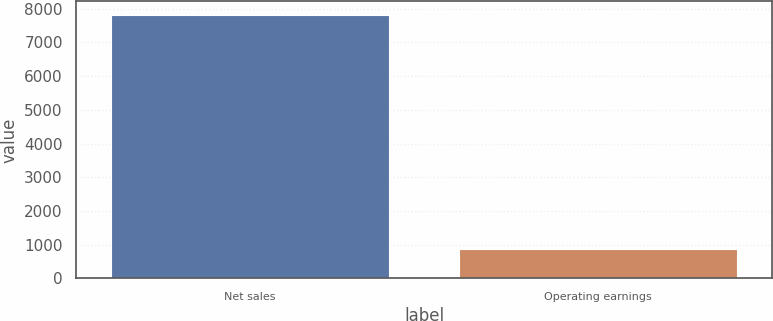Convert chart to OTSL. <chart><loc_0><loc_0><loc_500><loc_500><bar_chart><fcel>Net sales<fcel>Operating earnings<nl><fcel>7826<fcel>865<nl></chart> 